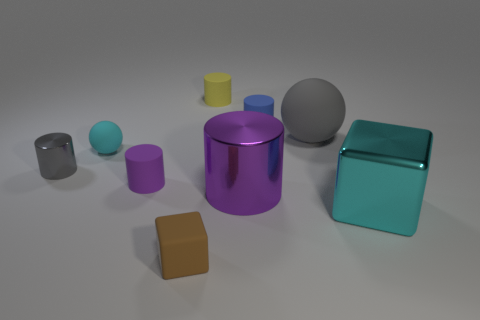Subtract all big purple metal cylinders. How many cylinders are left? 4 Subtract all cyan cylinders. Subtract all green blocks. How many cylinders are left? 5 Add 1 large cyan objects. How many objects exist? 10 Subtract all spheres. How many objects are left? 7 Add 8 matte blocks. How many matte blocks are left? 9 Add 7 big green shiny cubes. How many big green shiny cubes exist? 7 Subtract 0 gray cubes. How many objects are left? 9 Subtract all blue things. Subtract all cyan things. How many objects are left? 6 